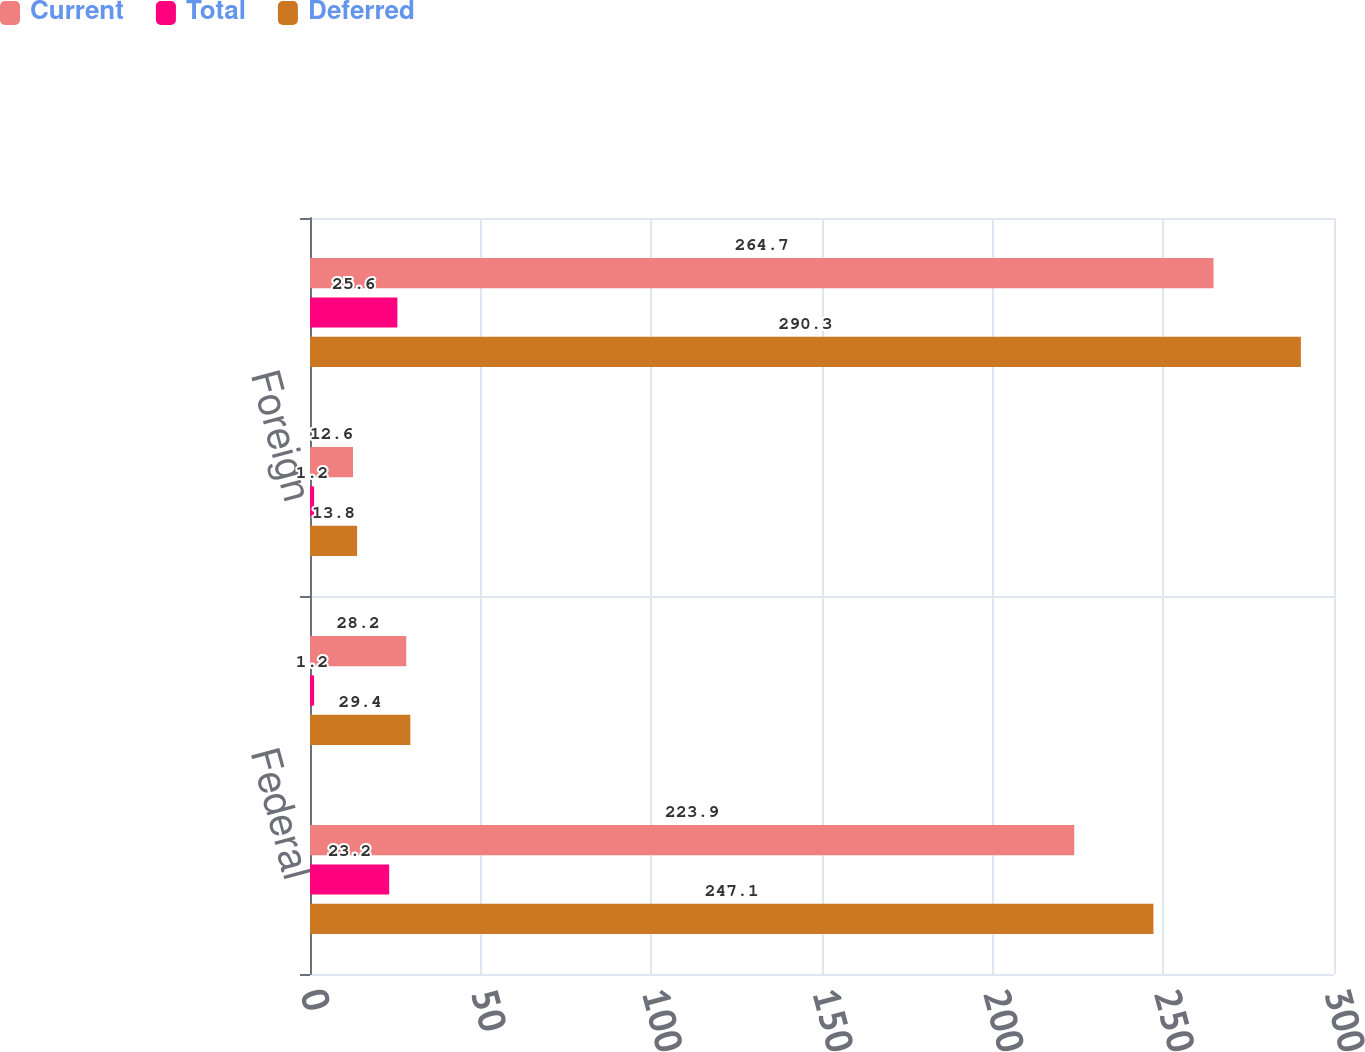Convert chart to OTSL. <chart><loc_0><loc_0><loc_500><loc_500><stacked_bar_chart><ecel><fcel>Federal<fcel>State<fcel>Foreign<fcel>Income tax expense<nl><fcel>Current<fcel>223.9<fcel>28.2<fcel>12.6<fcel>264.7<nl><fcel>Total<fcel>23.2<fcel>1.2<fcel>1.2<fcel>25.6<nl><fcel>Deferred<fcel>247.1<fcel>29.4<fcel>13.8<fcel>290.3<nl></chart> 